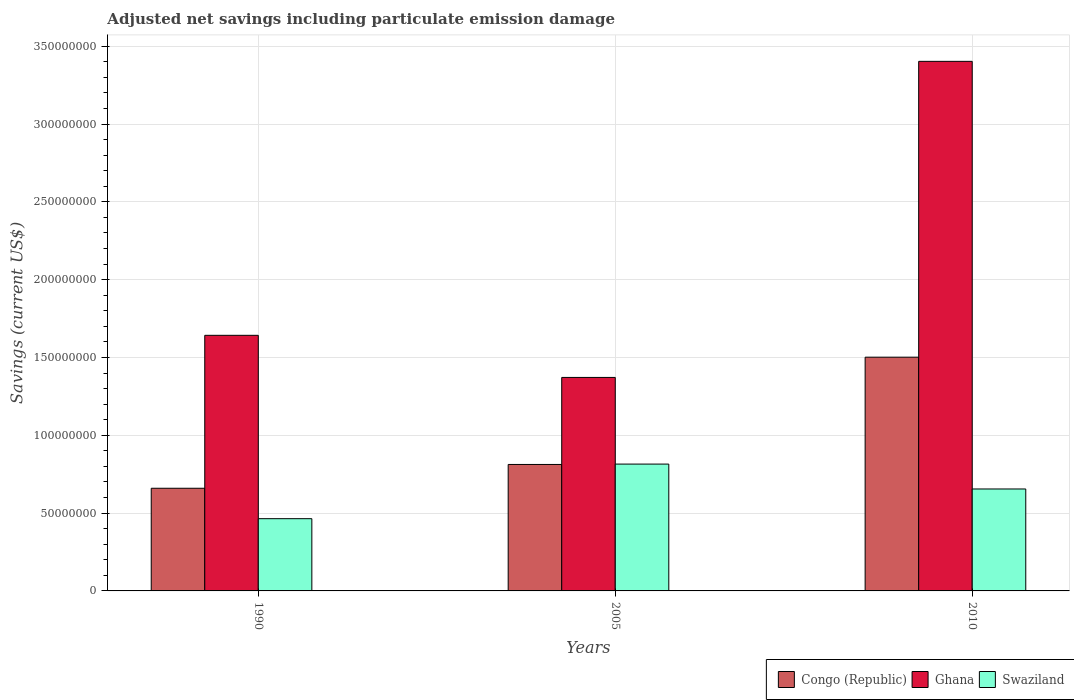Are the number of bars per tick equal to the number of legend labels?
Your response must be concise. Yes. Are the number of bars on each tick of the X-axis equal?
Your response must be concise. Yes. How many bars are there on the 3rd tick from the left?
Provide a short and direct response. 3. How many bars are there on the 1st tick from the right?
Keep it short and to the point. 3. What is the net savings in Swaziland in 2005?
Provide a short and direct response. 8.15e+07. Across all years, what is the maximum net savings in Swaziland?
Offer a terse response. 8.15e+07. Across all years, what is the minimum net savings in Ghana?
Give a very brief answer. 1.37e+08. In which year was the net savings in Swaziland maximum?
Ensure brevity in your answer.  2005. What is the total net savings in Congo (Republic) in the graph?
Ensure brevity in your answer.  2.97e+08. What is the difference between the net savings in Congo (Republic) in 1990 and that in 2010?
Provide a short and direct response. -8.42e+07. What is the difference between the net savings in Congo (Republic) in 2010 and the net savings in Swaziland in 2005?
Make the answer very short. 6.87e+07. What is the average net savings in Congo (Republic) per year?
Provide a succinct answer. 9.91e+07. In the year 1990, what is the difference between the net savings in Ghana and net savings in Congo (Republic)?
Give a very brief answer. 9.83e+07. In how many years, is the net savings in Congo (Republic) greater than 320000000 US$?
Your answer should be very brief. 0. What is the ratio of the net savings in Ghana in 1990 to that in 2010?
Offer a very short reply. 0.48. Is the net savings in Congo (Republic) in 1990 less than that in 2005?
Offer a very short reply. Yes. Is the difference between the net savings in Ghana in 1990 and 2010 greater than the difference between the net savings in Congo (Republic) in 1990 and 2010?
Your answer should be very brief. No. What is the difference between the highest and the second highest net savings in Congo (Republic)?
Ensure brevity in your answer.  6.89e+07. What is the difference between the highest and the lowest net savings in Ghana?
Your response must be concise. 2.03e+08. In how many years, is the net savings in Ghana greater than the average net savings in Ghana taken over all years?
Give a very brief answer. 1. Is the sum of the net savings in Swaziland in 1990 and 2010 greater than the maximum net savings in Ghana across all years?
Offer a very short reply. No. What does the 3rd bar from the left in 1990 represents?
Your answer should be compact. Swaziland. What does the 3rd bar from the right in 2010 represents?
Offer a terse response. Congo (Republic). How many years are there in the graph?
Offer a very short reply. 3. What is the difference between two consecutive major ticks on the Y-axis?
Your answer should be compact. 5.00e+07. Are the values on the major ticks of Y-axis written in scientific E-notation?
Provide a short and direct response. No. Does the graph contain grids?
Keep it short and to the point. Yes. Where does the legend appear in the graph?
Provide a succinct answer. Bottom right. How are the legend labels stacked?
Your answer should be very brief. Horizontal. What is the title of the graph?
Your answer should be very brief. Adjusted net savings including particulate emission damage. Does "Tonga" appear as one of the legend labels in the graph?
Your answer should be very brief. No. What is the label or title of the X-axis?
Provide a short and direct response. Years. What is the label or title of the Y-axis?
Offer a terse response. Savings (current US$). What is the Savings (current US$) of Congo (Republic) in 1990?
Your response must be concise. 6.60e+07. What is the Savings (current US$) in Ghana in 1990?
Give a very brief answer. 1.64e+08. What is the Savings (current US$) in Swaziland in 1990?
Provide a succinct answer. 4.64e+07. What is the Savings (current US$) in Congo (Republic) in 2005?
Ensure brevity in your answer.  8.13e+07. What is the Savings (current US$) of Ghana in 2005?
Make the answer very short. 1.37e+08. What is the Savings (current US$) of Swaziland in 2005?
Offer a terse response. 8.15e+07. What is the Savings (current US$) of Congo (Republic) in 2010?
Offer a terse response. 1.50e+08. What is the Savings (current US$) of Ghana in 2010?
Your answer should be very brief. 3.40e+08. What is the Savings (current US$) in Swaziland in 2010?
Offer a terse response. 6.55e+07. Across all years, what is the maximum Savings (current US$) of Congo (Republic)?
Give a very brief answer. 1.50e+08. Across all years, what is the maximum Savings (current US$) in Ghana?
Offer a terse response. 3.40e+08. Across all years, what is the maximum Savings (current US$) in Swaziland?
Provide a short and direct response. 8.15e+07. Across all years, what is the minimum Savings (current US$) of Congo (Republic)?
Ensure brevity in your answer.  6.60e+07. Across all years, what is the minimum Savings (current US$) in Ghana?
Ensure brevity in your answer.  1.37e+08. Across all years, what is the minimum Savings (current US$) of Swaziland?
Provide a succinct answer. 4.64e+07. What is the total Savings (current US$) of Congo (Republic) in the graph?
Ensure brevity in your answer.  2.97e+08. What is the total Savings (current US$) of Ghana in the graph?
Your response must be concise. 6.42e+08. What is the total Savings (current US$) of Swaziland in the graph?
Provide a short and direct response. 1.93e+08. What is the difference between the Savings (current US$) of Congo (Republic) in 1990 and that in 2005?
Your answer should be very brief. -1.53e+07. What is the difference between the Savings (current US$) of Ghana in 1990 and that in 2005?
Provide a succinct answer. 2.71e+07. What is the difference between the Savings (current US$) of Swaziland in 1990 and that in 2005?
Keep it short and to the point. -3.51e+07. What is the difference between the Savings (current US$) in Congo (Republic) in 1990 and that in 2010?
Provide a short and direct response. -8.42e+07. What is the difference between the Savings (current US$) in Ghana in 1990 and that in 2010?
Provide a succinct answer. -1.76e+08. What is the difference between the Savings (current US$) of Swaziland in 1990 and that in 2010?
Provide a succinct answer. -1.91e+07. What is the difference between the Savings (current US$) in Congo (Republic) in 2005 and that in 2010?
Offer a very short reply. -6.89e+07. What is the difference between the Savings (current US$) in Ghana in 2005 and that in 2010?
Give a very brief answer. -2.03e+08. What is the difference between the Savings (current US$) of Swaziland in 2005 and that in 2010?
Provide a short and direct response. 1.60e+07. What is the difference between the Savings (current US$) of Congo (Republic) in 1990 and the Savings (current US$) of Ghana in 2005?
Ensure brevity in your answer.  -7.12e+07. What is the difference between the Savings (current US$) in Congo (Republic) in 1990 and the Savings (current US$) in Swaziland in 2005?
Keep it short and to the point. -1.55e+07. What is the difference between the Savings (current US$) in Ghana in 1990 and the Savings (current US$) in Swaziland in 2005?
Provide a short and direct response. 8.27e+07. What is the difference between the Savings (current US$) of Congo (Republic) in 1990 and the Savings (current US$) of Ghana in 2010?
Provide a short and direct response. -2.74e+08. What is the difference between the Savings (current US$) in Congo (Republic) in 1990 and the Savings (current US$) in Swaziland in 2010?
Your answer should be compact. 4.62e+05. What is the difference between the Savings (current US$) of Ghana in 1990 and the Savings (current US$) of Swaziland in 2010?
Your answer should be very brief. 9.87e+07. What is the difference between the Savings (current US$) of Congo (Republic) in 2005 and the Savings (current US$) of Ghana in 2010?
Your answer should be compact. -2.59e+08. What is the difference between the Savings (current US$) of Congo (Republic) in 2005 and the Savings (current US$) of Swaziland in 2010?
Your answer should be compact. 1.57e+07. What is the difference between the Savings (current US$) in Ghana in 2005 and the Savings (current US$) in Swaziland in 2010?
Your answer should be very brief. 7.17e+07. What is the average Savings (current US$) of Congo (Republic) per year?
Provide a succinct answer. 9.91e+07. What is the average Savings (current US$) of Ghana per year?
Keep it short and to the point. 2.14e+08. What is the average Savings (current US$) in Swaziland per year?
Make the answer very short. 6.45e+07. In the year 1990, what is the difference between the Savings (current US$) in Congo (Republic) and Savings (current US$) in Ghana?
Provide a short and direct response. -9.83e+07. In the year 1990, what is the difference between the Savings (current US$) of Congo (Republic) and Savings (current US$) of Swaziland?
Ensure brevity in your answer.  1.95e+07. In the year 1990, what is the difference between the Savings (current US$) of Ghana and Savings (current US$) of Swaziland?
Offer a very short reply. 1.18e+08. In the year 2005, what is the difference between the Savings (current US$) in Congo (Republic) and Savings (current US$) in Ghana?
Offer a terse response. -5.59e+07. In the year 2005, what is the difference between the Savings (current US$) in Congo (Republic) and Savings (current US$) in Swaziland?
Your answer should be compact. -2.42e+05. In the year 2005, what is the difference between the Savings (current US$) in Ghana and Savings (current US$) in Swaziland?
Ensure brevity in your answer.  5.57e+07. In the year 2010, what is the difference between the Savings (current US$) of Congo (Republic) and Savings (current US$) of Ghana?
Your response must be concise. -1.90e+08. In the year 2010, what is the difference between the Savings (current US$) in Congo (Republic) and Savings (current US$) in Swaziland?
Your answer should be very brief. 8.47e+07. In the year 2010, what is the difference between the Savings (current US$) of Ghana and Savings (current US$) of Swaziland?
Offer a terse response. 2.75e+08. What is the ratio of the Savings (current US$) in Congo (Republic) in 1990 to that in 2005?
Offer a terse response. 0.81. What is the ratio of the Savings (current US$) of Ghana in 1990 to that in 2005?
Make the answer very short. 1.2. What is the ratio of the Savings (current US$) in Swaziland in 1990 to that in 2005?
Provide a short and direct response. 0.57. What is the ratio of the Savings (current US$) in Congo (Republic) in 1990 to that in 2010?
Your answer should be very brief. 0.44. What is the ratio of the Savings (current US$) of Ghana in 1990 to that in 2010?
Make the answer very short. 0.48. What is the ratio of the Savings (current US$) in Swaziland in 1990 to that in 2010?
Your answer should be compact. 0.71. What is the ratio of the Savings (current US$) in Congo (Republic) in 2005 to that in 2010?
Offer a very short reply. 0.54. What is the ratio of the Savings (current US$) of Ghana in 2005 to that in 2010?
Give a very brief answer. 0.4. What is the ratio of the Savings (current US$) in Swaziland in 2005 to that in 2010?
Keep it short and to the point. 1.24. What is the difference between the highest and the second highest Savings (current US$) in Congo (Republic)?
Offer a terse response. 6.89e+07. What is the difference between the highest and the second highest Savings (current US$) in Ghana?
Make the answer very short. 1.76e+08. What is the difference between the highest and the second highest Savings (current US$) of Swaziland?
Keep it short and to the point. 1.60e+07. What is the difference between the highest and the lowest Savings (current US$) in Congo (Republic)?
Offer a very short reply. 8.42e+07. What is the difference between the highest and the lowest Savings (current US$) in Ghana?
Offer a terse response. 2.03e+08. What is the difference between the highest and the lowest Savings (current US$) of Swaziland?
Your response must be concise. 3.51e+07. 